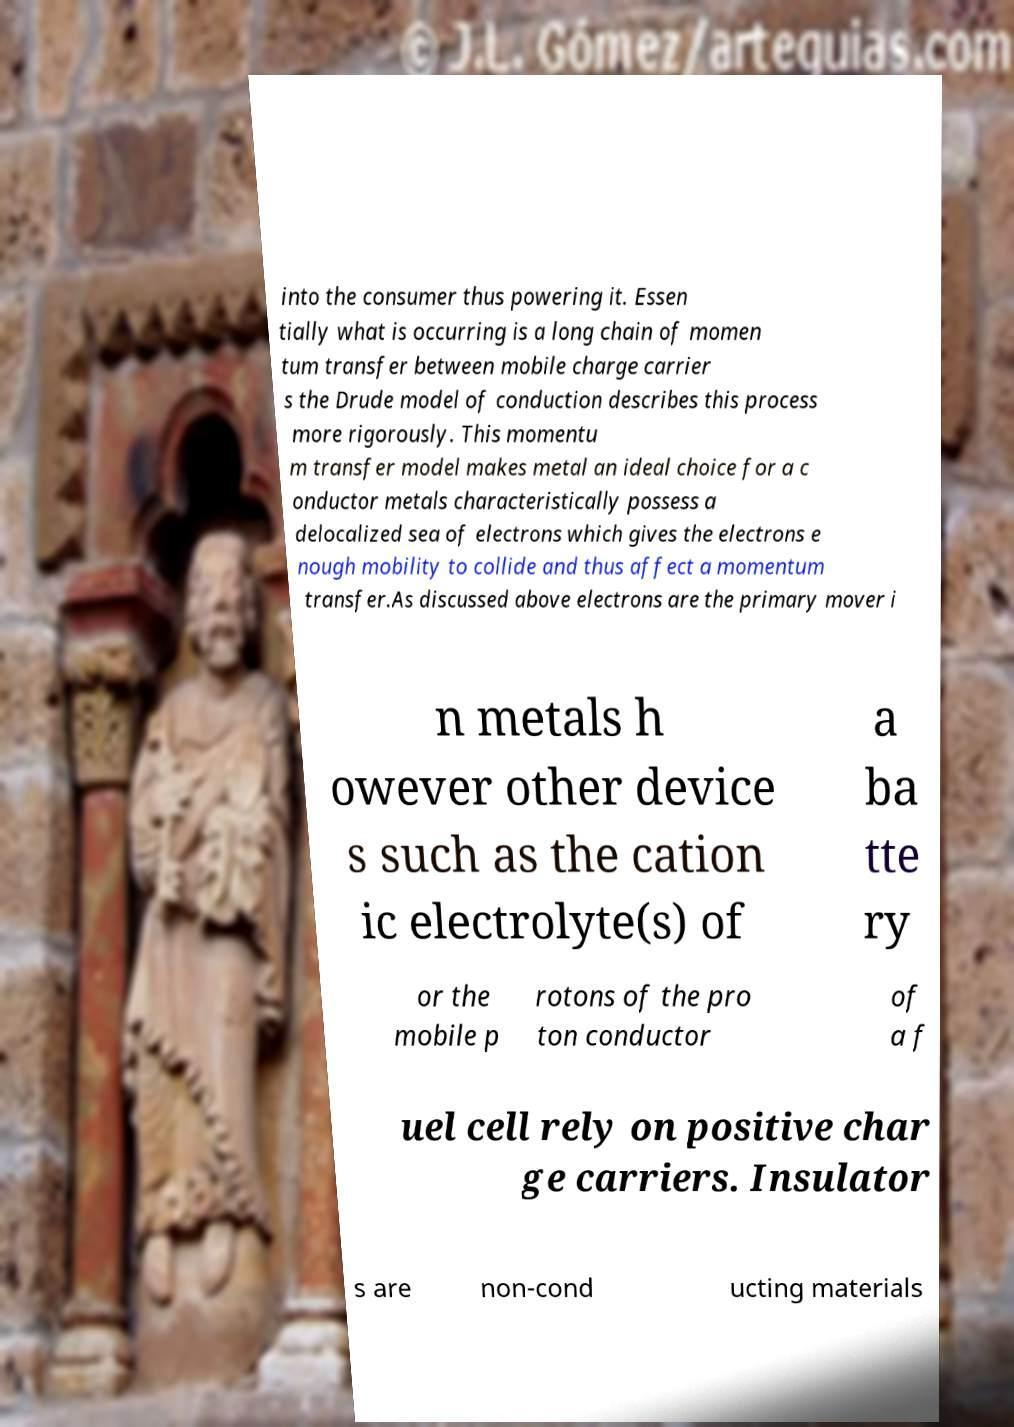Please identify and transcribe the text found in this image. into the consumer thus powering it. Essen tially what is occurring is a long chain of momen tum transfer between mobile charge carrier s the Drude model of conduction describes this process more rigorously. This momentu m transfer model makes metal an ideal choice for a c onductor metals characteristically possess a delocalized sea of electrons which gives the electrons e nough mobility to collide and thus affect a momentum transfer.As discussed above electrons are the primary mover i n metals h owever other device s such as the cation ic electrolyte(s) of a ba tte ry or the mobile p rotons of the pro ton conductor of a f uel cell rely on positive char ge carriers. Insulator s are non-cond ucting materials 